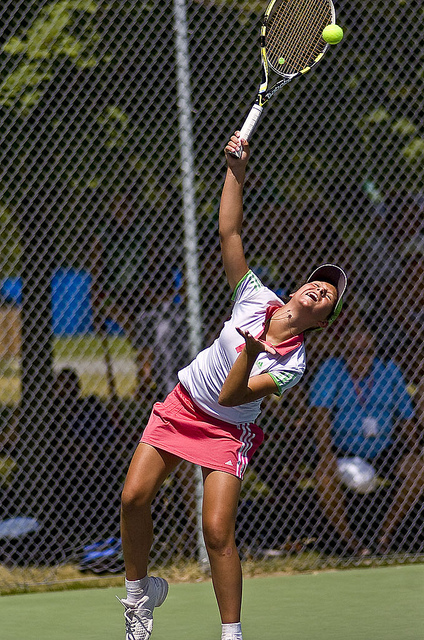What brand of tennis racket is she holding? Based on the colors and pattern visible on the tennis racket, it looks similar to models typically made by Wilson, although without a clearer view of the logo, this is an informed speculation rather than a certainty. 